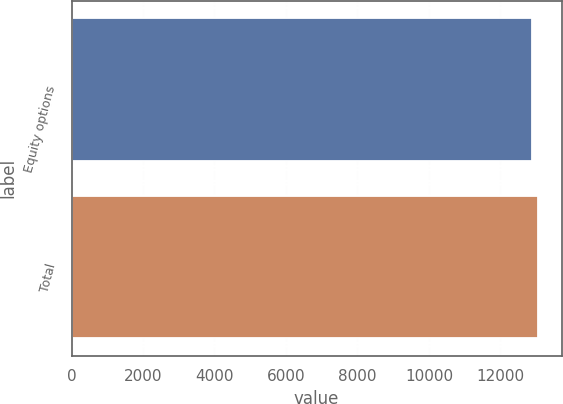Convert chart. <chart><loc_0><loc_0><loc_500><loc_500><bar_chart><fcel>Equity options<fcel>Total<nl><fcel>12891<fcel>13057<nl></chart> 